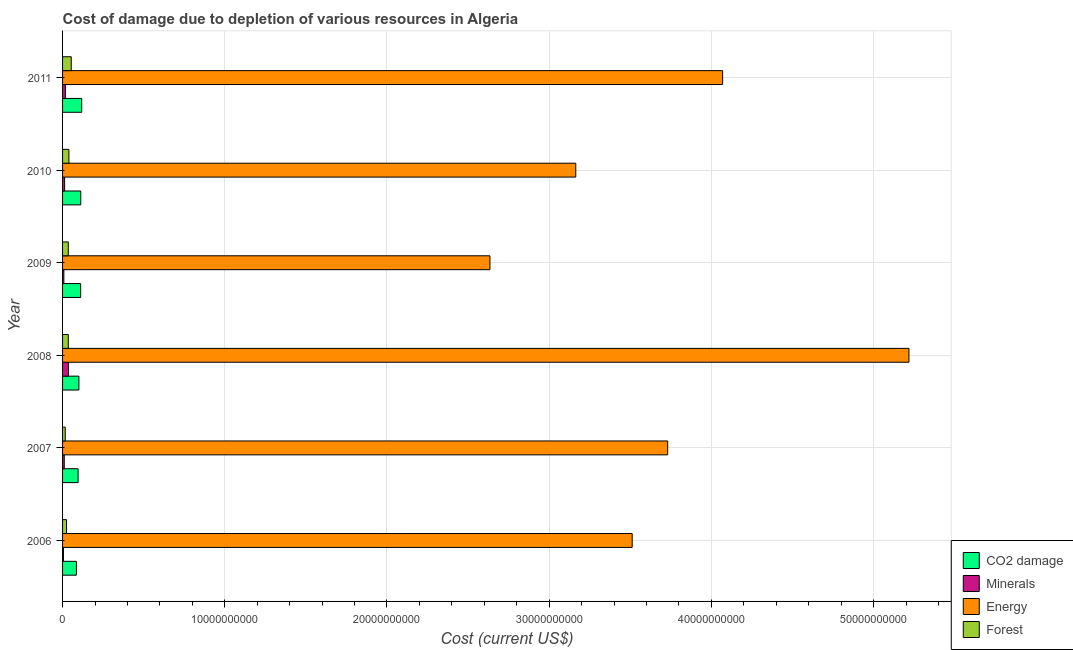How many different coloured bars are there?
Make the answer very short. 4. Are the number of bars per tick equal to the number of legend labels?
Keep it short and to the point. Yes. How many bars are there on the 6th tick from the bottom?
Your response must be concise. 4. What is the cost of damage due to depletion of energy in 2009?
Your response must be concise. 2.63e+1. Across all years, what is the maximum cost of damage due to depletion of energy?
Your response must be concise. 5.22e+1. Across all years, what is the minimum cost of damage due to depletion of minerals?
Ensure brevity in your answer.  5.54e+07. In which year was the cost of damage due to depletion of coal maximum?
Make the answer very short. 2011. In which year was the cost of damage due to depletion of coal minimum?
Provide a succinct answer. 2006. What is the total cost of damage due to depletion of energy in the graph?
Provide a succinct answer. 2.23e+11. What is the difference between the cost of damage due to depletion of energy in 2008 and that in 2011?
Provide a succinct answer. 1.15e+1. What is the difference between the cost of damage due to depletion of coal in 2010 and the cost of damage due to depletion of energy in 2011?
Keep it short and to the point. -3.96e+1. What is the average cost of damage due to depletion of coal per year?
Your answer should be very brief. 1.04e+09. In the year 2009, what is the difference between the cost of damage due to depletion of energy and cost of damage due to depletion of coal?
Offer a very short reply. 2.52e+1. What is the ratio of the cost of damage due to depletion of coal in 2008 to that in 2010?
Give a very brief answer. 0.9. What is the difference between the highest and the second highest cost of damage due to depletion of forests?
Your answer should be compact. 1.43e+08. What is the difference between the highest and the lowest cost of damage due to depletion of minerals?
Offer a terse response. 3.06e+08. In how many years, is the cost of damage due to depletion of coal greater than the average cost of damage due to depletion of coal taken over all years?
Make the answer very short. 3. Is it the case that in every year, the sum of the cost of damage due to depletion of minerals and cost of damage due to depletion of coal is greater than the sum of cost of damage due to depletion of forests and cost of damage due to depletion of energy?
Offer a very short reply. No. What does the 2nd bar from the top in 2006 represents?
Your answer should be very brief. Energy. What does the 3rd bar from the bottom in 2009 represents?
Offer a terse response. Energy. Is it the case that in every year, the sum of the cost of damage due to depletion of coal and cost of damage due to depletion of minerals is greater than the cost of damage due to depletion of energy?
Give a very brief answer. No. Are the values on the major ticks of X-axis written in scientific E-notation?
Provide a short and direct response. No. Does the graph contain any zero values?
Provide a short and direct response. No. How many legend labels are there?
Provide a succinct answer. 4. How are the legend labels stacked?
Give a very brief answer. Vertical. What is the title of the graph?
Offer a very short reply. Cost of damage due to depletion of various resources in Algeria . Does "Coal" appear as one of the legend labels in the graph?
Offer a terse response. No. What is the label or title of the X-axis?
Your answer should be compact. Cost (current US$). What is the label or title of the Y-axis?
Ensure brevity in your answer.  Year. What is the Cost (current US$) of CO2 damage in 2006?
Make the answer very short. 8.52e+08. What is the Cost (current US$) in Minerals in 2006?
Ensure brevity in your answer.  5.54e+07. What is the Cost (current US$) of Energy in 2006?
Provide a succinct answer. 3.51e+1. What is the Cost (current US$) of Forest in 2006?
Make the answer very short. 2.44e+08. What is the Cost (current US$) of CO2 damage in 2007?
Offer a terse response. 9.57e+08. What is the Cost (current US$) of Minerals in 2007?
Ensure brevity in your answer.  1.04e+08. What is the Cost (current US$) in Energy in 2007?
Provide a short and direct response. 3.73e+1. What is the Cost (current US$) of Forest in 2007?
Ensure brevity in your answer.  1.64e+08. What is the Cost (current US$) of CO2 damage in 2008?
Make the answer very short. 1.01e+09. What is the Cost (current US$) in Minerals in 2008?
Ensure brevity in your answer.  3.61e+08. What is the Cost (current US$) in Energy in 2008?
Keep it short and to the point. 5.22e+1. What is the Cost (current US$) in Forest in 2008?
Offer a terse response. 3.55e+08. What is the Cost (current US$) in CO2 damage in 2009?
Ensure brevity in your answer.  1.12e+09. What is the Cost (current US$) of Minerals in 2009?
Make the answer very short. 7.99e+07. What is the Cost (current US$) in Energy in 2009?
Your response must be concise. 2.63e+1. What is the Cost (current US$) of Forest in 2009?
Give a very brief answer. 3.52e+08. What is the Cost (current US$) in CO2 damage in 2010?
Provide a short and direct response. 1.12e+09. What is the Cost (current US$) in Minerals in 2010?
Ensure brevity in your answer.  1.26e+08. What is the Cost (current US$) in Energy in 2010?
Your answer should be very brief. 3.16e+1. What is the Cost (current US$) in Forest in 2010?
Make the answer very short. 3.91e+08. What is the Cost (current US$) in CO2 damage in 2011?
Give a very brief answer. 1.18e+09. What is the Cost (current US$) of Minerals in 2011?
Ensure brevity in your answer.  1.73e+08. What is the Cost (current US$) in Energy in 2011?
Provide a succinct answer. 4.07e+1. What is the Cost (current US$) in Forest in 2011?
Make the answer very short. 5.34e+08. Across all years, what is the maximum Cost (current US$) of CO2 damage?
Keep it short and to the point. 1.18e+09. Across all years, what is the maximum Cost (current US$) of Minerals?
Offer a terse response. 3.61e+08. Across all years, what is the maximum Cost (current US$) of Energy?
Your answer should be very brief. 5.22e+1. Across all years, what is the maximum Cost (current US$) of Forest?
Provide a short and direct response. 5.34e+08. Across all years, what is the minimum Cost (current US$) in CO2 damage?
Provide a succinct answer. 8.52e+08. Across all years, what is the minimum Cost (current US$) of Minerals?
Give a very brief answer. 5.54e+07. Across all years, what is the minimum Cost (current US$) of Energy?
Make the answer very short. 2.63e+1. Across all years, what is the minimum Cost (current US$) of Forest?
Offer a very short reply. 1.64e+08. What is the total Cost (current US$) of CO2 damage in the graph?
Provide a short and direct response. 6.23e+09. What is the total Cost (current US$) in Minerals in the graph?
Your answer should be very brief. 8.99e+08. What is the total Cost (current US$) in Energy in the graph?
Offer a very short reply. 2.23e+11. What is the total Cost (current US$) of Forest in the graph?
Provide a short and direct response. 2.04e+09. What is the difference between the Cost (current US$) in CO2 damage in 2006 and that in 2007?
Give a very brief answer. -1.05e+08. What is the difference between the Cost (current US$) in Minerals in 2006 and that in 2007?
Your answer should be compact. -4.81e+07. What is the difference between the Cost (current US$) of Energy in 2006 and that in 2007?
Make the answer very short. -2.19e+09. What is the difference between the Cost (current US$) in Forest in 2006 and that in 2007?
Provide a short and direct response. 8.01e+07. What is the difference between the Cost (current US$) in CO2 damage in 2006 and that in 2008?
Ensure brevity in your answer.  -1.55e+08. What is the difference between the Cost (current US$) in Minerals in 2006 and that in 2008?
Ensure brevity in your answer.  -3.06e+08. What is the difference between the Cost (current US$) of Energy in 2006 and that in 2008?
Offer a very short reply. -1.71e+1. What is the difference between the Cost (current US$) in Forest in 2006 and that in 2008?
Your answer should be compact. -1.10e+08. What is the difference between the Cost (current US$) in CO2 damage in 2006 and that in 2009?
Provide a short and direct response. -2.63e+08. What is the difference between the Cost (current US$) of Minerals in 2006 and that in 2009?
Make the answer very short. -2.44e+07. What is the difference between the Cost (current US$) of Energy in 2006 and that in 2009?
Offer a terse response. 8.77e+09. What is the difference between the Cost (current US$) in Forest in 2006 and that in 2009?
Offer a terse response. -1.08e+08. What is the difference between the Cost (current US$) in CO2 damage in 2006 and that in 2010?
Make the answer very short. -2.69e+08. What is the difference between the Cost (current US$) in Minerals in 2006 and that in 2010?
Provide a short and direct response. -7.06e+07. What is the difference between the Cost (current US$) of Energy in 2006 and that in 2010?
Make the answer very short. 3.48e+09. What is the difference between the Cost (current US$) of Forest in 2006 and that in 2010?
Your answer should be very brief. -1.47e+08. What is the difference between the Cost (current US$) of CO2 damage in 2006 and that in 2011?
Make the answer very short. -3.28e+08. What is the difference between the Cost (current US$) of Minerals in 2006 and that in 2011?
Make the answer very short. -1.18e+08. What is the difference between the Cost (current US$) of Energy in 2006 and that in 2011?
Your response must be concise. -5.57e+09. What is the difference between the Cost (current US$) in Forest in 2006 and that in 2011?
Offer a very short reply. -2.90e+08. What is the difference between the Cost (current US$) of CO2 damage in 2007 and that in 2008?
Give a very brief answer. -4.96e+07. What is the difference between the Cost (current US$) of Minerals in 2007 and that in 2008?
Provide a succinct answer. -2.58e+08. What is the difference between the Cost (current US$) of Energy in 2007 and that in 2008?
Your answer should be very brief. -1.49e+1. What is the difference between the Cost (current US$) of Forest in 2007 and that in 2008?
Ensure brevity in your answer.  -1.90e+08. What is the difference between the Cost (current US$) in CO2 damage in 2007 and that in 2009?
Give a very brief answer. -1.58e+08. What is the difference between the Cost (current US$) of Minerals in 2007 and that in 2009?
Make the answer very short. 2.37e+07. What is the difference between the Cost (current US$) of Energy in 2007 and that in 2009?
Your answer should be compact. 1.10e+1. What is the difference between the Cost (current US$) in Forest in 2007 and that in 2009?
Give a very brief answer. -1.88e+08. What is the difference between the Cost (current US$) of CO2 damage in 2007 and that in 2010?
Provide a succinct answer. -1.64e+08. What is the difference between the Cost (current US$) in Minerals in 2007 and that in 2010?
Ensure brevity in your answer.  -2.25e+07. What is the difference between the Cost (current US$) of Energy in 2007 and that in 2010?
Offer a terse response. 5.67e+09. What is the difference between the Cost (current US$) in Forest in 2007 and that in 2010?
Ensure brevity in your answer.  -2.27e+08. What is the difference between the Cost (current US$) in CO2 damage in 2007 and that in 2011?
Offer a very short reply. -2.23e+08. What is the difference between the Cost (current US$) in Minerals in 2007 and that in 2011?
Ensure brevity in your answer.  -6.94e+07. What is the difference between the Cost (current US$) of Energy in 2007 and that in 2011?
Keep it short and to the point. -3.39e+09. What is the difference between the Cost (current US$) of Forest in 2007 and that in 2011?
Your answer should be compact. -3.70e+08. What is the difference between the Cost (current US$) in CO2 damage in 2008 and that in 2009?
Your answer should be very brief. -1.08e+08. What is the difference between the Cost (current US$) of Minerals in 2008 and that in 2009?
Ensure brevity in your answer.  2.81e+08. What is the difference between the Cost (current US$) in Energy in 2008 and that in 2009?
Your response must be concise. 2.58e+1. What is the difference between the Cost (current US$) of Forest in 2008 and that in 2009?
Keep it short and to the point. 2.40e+06. What is the difference between the Cost (current US$) of CO2 damage in 2008 and that in 2010?
Offer a terse response. -1.14e+08. What is the difference between the Cost (current US$) of Minerals in 2008 and that in 2010?
Give a very brief answer. 2.35e+08. What is the difference between the Cost (current US$) of Energy in 2008 and that in 2010?
Offer a terse response. 2.05e+1. What is the difference between the Cost (current US$) of Forest in 2008 and that in 2010?
Offer a terse response. -3.65e+07. What is the difference between the Cost (current US$) in CO2 damage in 2008 and that in 2011?
Offer a terse response. -1.73e+08. What is the difference between the Cost (current US$) in Minerals in 2008 and that in 2011?
Your response must be concise. 1.88e+08. What is the difference between the Cost (current US$) in Energy in 2008 and that in 2011?
Provide a short and direct response. 1.15e+1. What is the difference between the Cost (current US$) in Forest in 2008 and that in 2011?
Your response must be concise. -1.80e+08. What is the difference between the Cost (current US$) of CO2 damage in 2009 and that in 2010?
Provide a short and direct response. -5.77e+06. What is the difference between the Cost (current US$) in Minerals in 2009 and that in 2010?
Give a very brief answer. -4.61e+07. What is the difference between the Cost (current US$) in Energy in 2009 and that in 2010?
Ensure brevity in your answer.  -5.29e+09. What is the difference between the Cost (current US$) of Forest in 2009 and that in 2010?
Offer a terse response. -3.89e+07. What is the difference between the Cost (current US$) of CO2 damage in 2009 and that in 2011?
Keep it short and to the point. -6.50e+07. What is the difference between the Cost (current US$) in Minerals in 2009 and that in 2011?
Your answer should be compact. -9.31e+07. What is the difference between the Cost (current US$) of Energy in 2009 and that in 2011?
Provide a short and direct response. -1.43e+1. What is the difference between the Cost (current US$) in Forest in 2009 and that in 2011?
Keep it short and to the point. -1.82e+08. What is the difference between the Cost (current US$) of CO2 damage in 2010 and that in 2011?
Your answer should be very brief. -5.92e+07. What is the difference between the Cost (current US$) in Minerals in 2010 and that in 2011?
Your answer should be very brief. -4.69e+07. What is the difference between the Cost (current US$) in Energy in 2010 and that in 2011?
Ensure brevity in your answer.  -9.05e+09. What is the difference between the Cost (current US$) of Forest in 2010 and that in 2011?
Offer a very short reply. -1.43e+08. What is the difference between the Cost (current US$) of CO2 damage in 2006 and the Cost (current US$) of Minerals in 2007?
Your response must be concise. 7.48e+08. What is the difference between the Cost (current US$) in CO2 damage in 2006 and the Cost (current US$) in Energy in 2007?
Provide a short and direct response. -3.65e+1. What is the difference between the Cost (current US$) in CO2 damage in 2006 and the Cost (current US$) in Forest in 2007?
Ensure brevity in your answer.  6.88e+08. What is the difference between the Cost (current US$) in Minerals in 2006 and the Cost (current US$) in Energy in 2007?
Your answer should be very brief. -3.72e+1. What is the difference between the Cost (current US$) in Minerals in 2006 and the Cost (current US$) in Forest in 2007?
Offer a terse response. -1.09e+08. What is the difference between the Cost (current US$) in Energy in 2006 and the Cost (current US$) in Forest in 2007?
Make the answer very short. 3.50e+1. What is the difference between the Cost (current US$) of CO2 damage in 2006 and the Cost (current US$) of Minerals in 2008?
Make the answer very short. 4.91e+08. What is the difference between the Cost (current US$) in CO2 damage in 2006 and the Cost (current US$) in Energy in 2008?
Keep it short and to the point. -5.13e+1. What is the difference between the Cost (current US$) of CO2 damage in 2006 and the Cost (current US$) of Forest in 2008?
Your answer should be very brief. 4.97e+08. What is the difference between the Cost (current US$) of Minerals in 2006 and the Cost (current US$) of Energy in 2008?
Your response must be concise. -5.21e+1. What is the difference between the Cost (current US$) of Minerals in 2006 and the Cost (current US$) of Forest in 2008?
Keep it short and to the point. -2.99e+08. What is the difference between the Cost (current US$) of Energy in 2006 and the Cost (current US$) of Forest in 2008?
Provide a succinct answer. 3.48e+1. What is the difference between the Cost (current US$) in CO2 damage in 2006 and the Cost (current US$) in Minerals in 2009?
Offer a very short reply. 7.72e+08. What is the difference between the Cost (current US$) in CO2 damage in 2006 and the Cost (current US$) in Energy in 2009?
Provide a short and direct response. -2.55e+1. What is the difference between the Cost (current US$) of CO2 damage in 2006 and the Cost (current US$) of Forest in 2009?
Ensure brevity in your answer.  5.00e+08. What is the difference between the Cost (current US$) in Minerals in 2006 and the Cost (current US$) in Energy in 2009?
Ensure brevity in your answer.  -2.63e+1. What is the difference between the Cost (current US$) of Minerals in 2006 and the Cost (current US$) of Forest in 2009?
Your response must be concise. -2.97e+08. What is the difference between the Cost (current US$) of Energy in 2006 and the Cost (current US$) of Forest in 2009?
Keep it short and to the point. 3.48e+1. What is the difference between the Cost (current US$) of CO2 damage in 2006 and the Cost (current US$) of Minerals in 2010?
Provide a short and direct response. 7.26e+08. What is the difference between the Cost (current US$) of CO2 damage in 2006 and the Cost (current US$) of Energy in 2010?
Make the answer very short. -3.08e+1. What is the difference between the Cost (current US$) of CO2 damage in 2006 and the Cost (current US$) of Forest in 2010?
Your answer should be very brief. 4.61e+08. What is the difference between the Cost (current US$) of Minerals in 2006 and the Cost (current US$) of Energy in 2010?
Offer a very short reply. -3.16e+1. What is the difference between the Cost (current US$) of Minerals in 2006 and the Cost (current US$) of Forest in 2010?
Your answer should be very brief. -3.36e+08. What is the difference between the Cost (current US$) in Energy in 2006 and the Cost (current US$) in Forest in 2010?
Give a very brief answer. 3.47e+1. What is the difference between the Cost (current US$) of CO2 damage in 2006 and the Cost (current US$) of Minerals in 2011?
Keep it short and to the point. 6.79e+08. What is the difference between the Cost (current US$) in CO2 damage in 2006 and the Cost (current US$) in Energy in 2011?
Make the answer very short. -3.98e+1. What is the difference between the Cost (current US$) in CO2 damage in 2006 and the Cost (current US$) in Forest in 2011?
Offer a very short reply. 3.18e+08. What is the difference between the Cost (current US$) in Minerals in 2006 and the Cost (current US$) in Energy in 2011?
Offer a terse response. -4.06e+1. What is the difference between the Cost (current US$) of Minerals in 2006 and the Cost (current US$) of Forest in 2011?
Your answer should be very brief. -4.79e+08. What is the difference between the Cost (current US$) of Energy in 2006 and the Cost (current US$) of Forest in 2011?
Ensure brevity in your answer.  3.46e+1. What is the difference between the Cost (current US$) in CO2 damage in 2007 and the Cost (current US$) in Minerals in 2008?
Provide a succinct answer. 5.96e+08. What is the difference between the Cost (current US$) in CO2 damage in 2007 and the Cost (current US$) in Energy in 2008?
Your answer should be compact. -5.12e+1. What is the difference between the Cost (current US$) of CO2 damage in 2007 and the Cost (current US$) of Forest in 2008?
Give a very brief answer. 6.03e+08. What is the difference between the Cost (current US$) of Minerals in 2007 and the Cost (current US$) of Energy in 2008?
Keep it short and to the point. -5.21e+1. What is the difference between the Cost (current US$) in Minerals in 2007 and the Cost (current US$) in Forest in 2008?
Provide a succinct answer. -2.51e+08. What is the difference between the Cost (current US$) of Energy in 2007 and the Cost (current US$) of Forest in 2008?
Give a very brief answer. 3.69e+1. What is the difference between the Cost (current US$) in CO2 damage in 2007 and the Cost (current US$) in Minerals in 2009?
Provide a succinct answer. 8.77e+08. What is the difference between the Cost (current US$) in CO2 damage in 2007 and the Cost (current US$) in Energy in 2009?
Provide a succinct answer. -2.54e+1. What is the difference between the Cost (current US$) in CO2 damage in 2007 and the Cost (current US$) in Forest in 2009?
Provide a succinct answer. 6.05e+08. What is the difference between the Cost (current US$) in Minerals in 2007 and the Cost (current US$) in Energy in 2009?
Your answer should be compact. -2.62e+1. What is the difference between the Cost (current US$) of Minerals in 2007 and the Cost (current US$) of Forest in 2009?
Offer a very short reply. -2.49e+08. What is the difference between the Cost (current US$) in Energy in 2007 and the Cost (current US$) in Forest in 2009?
Offer a very short reply. 3.70e+1. What is the difference between the Cost (current US$) of CO2 damage in 2007 and the Cost (current US$) of Minerals in 2010?
Offer a terse response. 8.31e+08. What is the difference between the Cost (current US$) of CO2 damage in 2007 and the Cost (current US$) of Energy in 2010?
Provide a succinct answer. -3.07e+1. What is the difference between the Cost (current US$) in CO2 damage in 2007 and the Cost (current US$) in Forest in 2010?
Provide a short and direct response. 5.66e+08. What is the difference between the Cost (current US$) of Minerals in 2007 and the Cost (current US$) of Energy in 2010?
Offer a terse response. -3.15e+1. What is the difference between the Cost (current US$) of Minerals in 2007 and the Cost (current US$) of Forest in 2010?
Give a very brief answer. -2.87e+08. What is the difference between the Cost (current US$) of Energy in 2007 and the Cost (current US$) of Forest in 2010?
Offer a terse response. 3.69e+1. What is the difference between the Cost (current US$) in CO2 damage in 2007 and the Cost (current US$) in Minerals in 2011?
Provide a succinct answer. 7.84e+08. What is the difference between the Cost (current US$) of CO2 damage in 2007 and the Cost (current US$) of Energy in 2011?
Your answer should be compact. -3.97e+1. What is the difference between the Cost (current US$) of CO2 damage in 2007 and the Cost (current US$) of Forest in 2011?
Provide a succinct answer. 4.23e+08. What is the difference between the Cost (current US$) of Minerals in 2007 and the Cost (current US$) of Energy in 2011?
Ensure brevity in your answer.  -4.06e+1. What is the difference between the Cost (current US$) of Minerals in 2007 and the Cost (current US$) of Forest in 2011?
Offer a very short reply. -4.31e+08. What is the difference between the Cost (current US$) of Energy in 2007 and the Cost (current US$) of Forest in 2011?
Provide a short and direct response. 3.68e+1. What is the difference between the Cost (current US$) of CO2 damage in 2008 and the Cost (current US$) of Minerals in 2009?
Keep it short and to the point. 9.27e+08. What is the difference between the Cost (current US$) in CO2 damage in 2008 and the Cost (current US$) in Energy in 2009?
Your answer should be compact. -2.53e+1. What is the difference between the Cost (current US$) of CO2 damage in 2008 and the Cost (current US$) of Forest in 2009?
Make the answer very short. 6.55e+08. What is the difference between the Cost (current US$) of Minerals in 2008 and the Cost (current US$) of Energy in 2009?
Give a very brief answer. -2.60e+1. What is the difference between the Cost (current US$) in Minerals in 2008 and the Cost (current US$) in Forest in 2009?
Ensure brevity in your answer.  8.99e+06. What is the difference between the Cost (current US$) in Energy in 2008 and the Cost (current US$) in Forest in 2009?
Keep it short and to the point. 5.18e+1. What is the difference between the Cost (current US$) in CO2 damage in 2008 and the Cost (current US$) in Minerals in 2010?
Ensure brevity in your answer.  8.81e+08. What is the difference between the Cost (current US$) in CO2 damage in 2008 and the Cost (current US$) in Energy in 2010?
Offer a terse response. -3.06e+1. What is the difference between the Cost (current US$) in CO2 damage in 2008 and the Cost (current US$) in Forest in 2010?
Offer a terse response. 6.16e+08. What is the difference between the Cost (current US$) in Minerals in 2008 and the Cost (current US$) in Energy in 2010?
Your answer should be very brief. -3.13e+1. What is the difference between the Cost (current US$) of Minerals in 2008 and the Cost (current US$) of Forest in 2010?
Offer a very short reply. -2.99e+07. What is the difference between the Cost (current US$) in Energy in 2008 and the Cost (current US$) in Forest in 2010?
Your response must be concise. 5.18e+1. What is the difference between the Cost (current US$) in CO2 damage in 2008 and the Cost (current US$) in Minerals in 2011?
Provide a short and direct response. 8.34e+08. What is the difference between the Cost (current US$) of CO2 damage in 2008 and the Cost (current US$) of Energy in 2011?
Keep it short and to the point. -3.97e+1. What is the difference between the Cost (current US$) of CO2 damage in 2008 and the Cost (current US$) of Forest in 2011?
Your response must be concise. 4.72e+08. What is the difference between the Cost (current US$) of Minerals in 2008 and the Cost (current US$) of Energy in 2011?
Offer a very short reply. -4.03e+1. What is the difference between the Cost (current US$) in Minerals in 2008 and the Cost (current US$) in Forest in 2011?
Offer a terse response. -1.73e+08. What is the difference between the Cost (current US$) in Energy in 2008 and the Cost (current US$) in Forest in 2011?
Give a very brief answer. 5.16e+1. What is the difference between the Cost (current US$) in CO2 damage in 2009 and the Cost (current US$) in Minerals in 2010?
Your response must be concise. 9.89e+08. What is the difference between the Cost (current US$) in CO2 damage in 2009 and the Cost (current US$) in Energy in 2010?
Provide a succinct answer. -3.05e+1. What is the difference between the Cost (current US$) in CO2 damage in 2009 and the Cost (current US$) in Forest in 2010?
Offer a very short reply. 7.24e+08. What is the difference between the Cost (current US$) of Minerals in 2009 and the Cost (current US$) of Energy in 2010?
Make the answer very short. -3.16e+1. What is the difference between the Cost (current US$) in Minerals in 2009 and the Cost (current US$) in Forest in 2010?
Your response must be concise. -3.11e+08. What is the difference between the Cost (current US$) of Energy in 2009 and the Cost (current US$) of Forest in 2010?
Your response must be concise. 2.60e+1. What is the difference between the Cost (current US$) in CO2 damage in 2009 and the Cost (current US$) in Minerals in 2011?
Give a very brief answer. 9.42e+08. What is the difference between the Cost (current US$) in CO2 damage in 2009 and the Cost (current US$) in Energy in 2011?
Make the answer very short. -3.96e+1. What is the difference between the Cost (current US$) in CO2 damage in 2009 and the Cost (current US$) in Forest in 2011?
Offer a terse response. 5.81e+08. What is the difference between the Cost (current US$) in Minerals in 2009 and the Cost (current US$) in Energy in 2011?
Provide a succinct answer. -4.06e+1. What is the difference between the Cost (current US$) of Minerals in 2009 and the Cost (current US$) of Forest in 2011?
Offer a terse response. -4.55e+08. What is the difference between the Cost (current US$) in Energy in 2009 and the Cost (current US$) in Forest in 2011?
Ensure brevity in your answer.  2.58e+1. What is the difference between the Cost (current US$) of CO2 damage in 2010 and the Cost (current US$) of Minerals in 2011?
Give a very brief answer. 9.48e+08. What is the difference between the Cost (current US$) of CO2 damage in 2010 and the Cost (current US$) of Energy in 2011?
Provide a succinct answer. -3.96e+1. What is the difference between the Cost (current US$) in CO2 damage in 2010 and the Cost (current US$) in Forest in 2011?
Provide a succinct answer. 5.87e+08. What is the difference between the Cost (current US$) of Minerals in 2010 and the Cost (current US$) of Energy in 2011?
Offer a very short reply. -4.06e+1. What is the difference between the Cost (current US$) in Minerals in 2010 and the Cost (current US$) in Forest in 2011?
Provide a short and direct response. -4.08e+08. What is the difference between the Cost (current US$) in Energy in 2010 and the Cost (current US$) in Forest in 2011?
Make the answer very short. 3.11e+1. What is the average Cost (current US$) in CO2 damage per year?
Your response must be concise. 1.04e+09. What is the average Cost (current US$) of Minerals per year?
Offer a terse response. 1.50e+08. What is the average Cost (current US$) of Energy per year?
Provide a succinct answer. 3.72e+1. What is the average Cost (current US$) of Forest per year?
Provide a short and direct response. 3.40e+08. In the year 2006, what is the difference between the Cost (current US$) of CO2 damage and Cost (current US$) of Minerals?
Offer a terse response. 7.97e+08. In the year 2006, what is the difference between the Cost (current US$) in CO2 damage and Cost (current US$) in Energy?
Make the answer very short. -3.43e+1. In the year 2006, what is the difference between the Cost (current US$) in CO2 damage and Cost (current US$) in Forest?
Offer a very short reply. 6.08e+08. In the year 2006, what is the difference between the Cost (current US$) in Minerals and Cost (current US$) in Energy?
Your answer should be compact. -3.51e+1. In the year 2006, what is the difference between the Cost (current US$) in Minerals and Cost (current US$) in Forest?
Provide a short and direct response. -1.89e+08. In the year 2006, what is the difference between the Cost (current US$) in Energy and Cost (current US$) in Forest?
Your answer should be compact. 3.49e+1. In the year 2007, what is the difference between the Cost (current US$) of CO2 damage and Cost (current US$) of Minerals?
Your answer should be very brief. 8.54e+08. In the year 2007, what is the difference between the Cost (current US$) of CO2 damage and Cost (current US$) of Energy?
Keep it short and to the point. -3.63e+1. In the year 2007, what is the difference between the Cost (current US$) of CO2 damage and Cost (current US$) of Forest?
Keep it short and to the point. 7.93e+08. In the year 2007, what is the difference between the Cost (current US$) of Minerals and Cost (current US$) of Energy?
Provide a short and direct response. -3.72e+1. In the year 2007, what is the difference between the Cost (current US$) in Minerals and Cost (current US$) in Forest?
Your answer should be compact. -6.09e+07. In the year 2007, what is the difference between the Cost (current US$) in Energy and Cost (current US$) in Forest?
Ensure brevity in your answer.  3.71e+1. In the year 2008, what is the difference between the Cost (current US$) of CO2 damage and Cost (current US$) of Minerals?
Offer a terse response. 6.46e+08. In the year 2008, what is the difference between the Cost (current US$) in CO2 damage and Cost (current US$) in Energy?
Ensure brevity in your answer.  -5.12e+1. In the year 2008, what is the difference between the Cost (current US$) of CO2 damage and Cost (current US$) of Forest?
Provide a succinct answer. 6.52e+08. In the year 2008, what is the difference between the Cost (current US$) in Minerals and Cost (current US$) in Energy?
Your answer should be compact. -5.18e+1. In the year 2008, what is the difference between the Cost (current US$) of Minerals and Cost (current US$) of Forest?
Offer a very short reply. 6.58e+06. In the year 2008, what is the difference between the Cost (current US$) of Energy and Cost (current US$) of Forest?
Make the answer very short. 5.18e+1. In the year 2009, what is the difference between the Cost (current US$) of CO2 damage and Cost (current US$) of Minerals?
Offer a terse response. 1.04e+09. In the year 2009, what is the difference between the Cost (current US$) of CO2 damage and Cost (current US$) of Energy?
Your answer should be very brief. -2.52e+1. In the year 2009, what is the difference between the Cost (current US$) of CO2 damage and Cost (current US$) of Forest?
Your answer should be compact. 7.63e+08. In the year 2009, what is the difference between the Cost (current US$) of Minerals and Cost (current US$) of Energy?
Your response must be concise. -2.63e+1. In the year 2009, what is the difference between the Cost (current US$) of Minerals and Cost (current US$) of Forest?
Your answer should be very brief. -2.72e+08. In the year 2009, what is the difference between the Cost (current US$) in Energy and Cost (current US$) in Forest?
Your answer should be very brief. 2.60e+1. In the year 2010, what is the difference between the Cost (current US$) in CO2 damage and Cost (current US$) in Minerals?
Keep it short and to the point. 9.95e+08. In the year 2010, what is the difference between the Cost (current US$) of CO2 damage and Cost (current US$) of Energy?
Offer a very short reply. -3.05e+1. In the year 2010, what is the difference between the Cost (current US$) in CO2 damage and Cost (current US$) in Forest?
Offer a very short reply. 7.30e+08. In the year 2010, what is the difference between the Cost (current US$) in Minerals and Cost (current US$) in Energy?
Offer a terse response. -3.15e+1. In the year 2010, what is the difference between the Cost (current US$) in Minerals and Cost (current US$) in Forest?
Make the answer very short. -2.65e+08. In the year 2010, what is the difference between the Cost (current US$) of Energy and Cost (current US$) of Forest?
Offer a terse response. 3.12e+1. In the year 2011, what is the difference between the Cost (current US$) of CO2 damage and Cost (current US$) of Minerals?
Provide a short and direct response. 1.01e+09. In the year 2011, what is the difference between the Cost (current US$) of CO2 damage and Cost (current US$) of Energy?
Your answer should be compact. -3.95e+1. In the year 2011, what is the difference between the Cost (current US$) of CO2 damage and Cost (current US$) of Forest?
Provide a succinct answer. 6.46e+08. In the year 2011, what is the difference between the Cost (current US$) of Minerals and Cost (current US$) of Energy?
Provide a short and direct response. -4.05e+1. In the year 2011, what is the difference between the Cost (current US$) in Minerals and Cost (current US$) in Forest?
Provide a short and direct response. -3.61e+08. In the year 2011, what is the difference between the Cost (current US$) in Energy and Cost (current US$) in Forest?
Your response must be concise. 4.02e+1. What is the ratio of the Cost (current US$) of CO2 damage in 2006 to that in 2007?
Give a very brief answer. 0.89. What is the ratio of the Cost (current US$) of Minerals in 2006 to that in 2007?
Ensure brevity in your answer.  0.54. What is the ratio of the Cost (current US$) of Energy in 2006 to that in 2007?
Your answer should be very brief. 0.94. What is the ratio of the Cost (current US$) of Forest in 2006 to that in 2007?
Your answer should be compact. 1.49. What is the ratio of the Cost (current US$) in CO2 damage in 2006 to that in 2008?
Your response must be concise. 0.85. What is the ratio of the Cost (current US$) in Minerals in 2006 to that in 2008?
Your answer should be compact. 0.15. What is the ratio of the Cost (current US$) of Energy in 2006 to that in 2008?
Offer a very short reply. 0.67. What is the ratio of the Cost (current US$) of Forest in 2006 to that in 2008?
Offer a terse response. 0.69. What is the ratio of the Cost (current US$) in CO2 damage in 2006 to that in 2009?
Your answer should be very brief. 0.76. What is the ratio of the Cost (current US$) in Minerals in 2006 to that in 2009?
Give a very brief answer. 0.69. What is the ratio of the Cost (current US$) of Energy in 2006 to that in 2009?
Offer a terse response. 1.33. What is the ratio of the Cost (current US$) in Forest in 2006 to that in 2009?
Your answer should be compact. 0.69. What is the ratio of the Cost (current US$) of CO2 damage in 2006 to that in 2010?
Keep it short and to the point. 0.76. What is the ratio of the Cost (current US$) of Minerals in 2006 to that in 2010?
Make the answer very short. 0.44. What is the ratio of the Cost (current US$) in Energy in 2006 to that in 2010?
Provide a short and direct response. 1.11. What is the ratio of the Cost (current US$) of Forest in 2006 to that in 2010?
Offer a very short reply. 0.63. What is the ratio of the Cost (current US$) of CO2 damage in 2006 to that in 2011?
Make the answer very short. 0.72. What is the ratio of the Cost (current US$) of Minerals in 2006 to that in 2011?
Give a very brief answer. 0.32. What is the ratio of the Cost (current US$) in Energy in 2006 to that in 2011?
Provide a short and direct response. 0.86. What is the ratio of the Cost (current US$) in Forest in 2006 to that in 2011?
Offer a terse response. 0.46. What is the ratio of the Cost (current US$) of CO2 damage in 2007 to that in 2008?
Offer a very short reply. 0.95. What is the ratio of the Cost (current US$) of Minerals in 2007 to that in 2008?
Your response must be concise. 0.29. What is the ratio of the Cost (current US$) in Energy in 2007 to that in 2008?
Offer a very short reply. 0.71. What is the ratio of the Cost (current US$) in Forest in 2007 to that in 2008?
Give a very brief answer. 0.46. What is the ratio of the Cost (current US$) of CO2 damage in 2007 to that in 2009?
Make the answer very short. 0.86. What is the ratio of the Cost (current US$) of Minerals in 2007 to that in 2009?
Offer a very short reply. 1.3. What is the ratio of the Cost (current US$) in Energy in 2007 to that in 2009?
Offer a very short reply. 1.42. What is the ratio of the Cost (current US$) of Forest in 2007 to that in 2009?
Provide a short and direct response. 0.47. What is the ratio of the Cost (current US$) in CO2 damage in 2007 to that in 2010?
Provide a succinct answer. 0.85. What is the ratio of the Cost (current US$) in Minerals in 2007 to that in 2010?
Your answer should be compact. 0.82. What is the ratio of the Cost (current US$) of Energy in 2007 to that in 2010?
Offer a very short reply. 1.18. What is the ratio of the Cost (current US$) of Forest in 2007 to that in 2010?
Your response must be concise. 0.42. What is the ratio of the Cost (current US$) of CO2 damage in 2007 to that in 2011?
Provide a succinct answer. 0.81. What is the ratio of the Cost (current US$) in Minerals in 2007 to that in 2011?
Your answer should be very brief. 0.6. What is the ratio of the Cost (current US$) in Energy in 2007 to that in 2011?
Keep it short and to the point. 0.92. What is the ratio of the Cost (current US$) in Forest in 2007 to that in 2011?
Your response must be concise. 0.31. What is the ratio of the Cost (current US$) of CO2 damage in 2008 to that in 2009?
Your response must be concise. 0.9. What is the ratio of the Cost (current US$) in Minerals in 2008 to that in 2009?
Your answer should be compact. 4.52. What is the ratio of the Cost (current US$) in Energy in 2008 to that in 2009?
Offer a very short reply. 1.98. What is the ratio of the Cost (current US$) of Forest in 2008 to that in 2009?
Offer a very short reply. 1.01. What is the ratio of the Cost (current US$) in CO2 damage in 2008 to that in 2010?
Your answer should be very brief. 0.9. What is the ratio of the Cost (current US$) in Minerals in 2008 to that in 2010?
Keep it short and to the point. 2.87. What is the ratio of the Cost (current US$) of Energy in 2008 to that in 2010?
Make the answer very short. 1.65. What is the ratio of the Cost (current US$) in Forest in 2008 to that in 2010?
Keep it short and to the point. 0.91. What is the ratio of the Cost (current US$) of CO2 damage in 2008 to that in 2011?
Your response must be concise. 0.85. What is the ratio of the Cost (current US$) in Minerals in 2008 to that in 2011?
Give a very brief answer. 2.09. What is the ratio of the Cost (current US$) of Energy in 2008 to that in 2011?
Give a very brief answer. 1.28. What is the ratio of the Cost (current US$) of Forest in 2008 to that in 2011?
Ensure brevity in your answer.  0.66. What is the ratio of the Cost (current US$) in CO2 damage in 2009 to that in 2010?
Ensure brevity in your answer.  0.99. What is the ratio of the Cost (current US$) of Minerals in 2009 to that in 2010?
Your answer should be compact. 0.63. What is the ratio of the Cost (current US$) in Energy in 2009 to that in 2010?
Give a very brief answer. 0.83. What is the ratio of the Cost (current US$) in Forest in 2009 to that in 2010?
Make the answer very short. 0.9. What is the ratio of the Cost (current US$) of CO2 damage in 2009 to that in 2011?
Offer a terse response. 0.94. What is the ratio of the Cost (current US$) in Minerals in 2009 to that in 2011?
Give a very brief answer. 0.46. What is the ratio of the Cost (current US$) in Energy in 2009 to that in 2011?
Your response must be concise. 0.65. What is the ratio of the Cost (current US$) in Forest in 2009 to that in 2011?
Your answer should be compact. 0.66. What is the ratio of the Cost (current US$) in CO2 damage in 2010 to that in 2011?
Provide a short and direct response. 0.95. What is the ratio of the Cost (current US$) of Minerals in 2010 to that in 2011?
Offer a very short reply. 0.73. What is the ratio of the Cost (current US$) of Energy in 2010 to that in 2011?
Offer a terse response. 0.78. What is the ratio of the Cost (current US$) of Forest in 2010 to that in 2011?
Ensure brevity in your answer.  0.73. What is the difference between the highest and the second highest Cost (current US$) in CO2 damage?
Give a very brief answer. 5.92e+07. What is the difference between the highest and the second highest Cost (current US$) of Minerals?
Offer a very short reply. 1.88e+08. What is the difference between the highest and the second highest Cost (current US$) of Energy?
Give a very brief answer. 1.15e+1. What is the difference between the highest and the second highest Cost (current US$) of Forest?
Provide a short and direct response. 1.43e+08. What is the difference between the highest and the lowest Cost (current US$) in CO2 damage?
Make the answer very short. 3.28e+08. What is the difference between the highest and the lowest Cost (current US$) in Minerals?
Provide a short and direct response. 3.06e+08. What is the difference between the highest and the lowest Cost (current US$) of Energy?
Provide a succinct answer. 2.58e+1. What is the difference between the highest and the lowest Cost (current US$) of Forest?
Offer a terse response. 3.70e+08. 